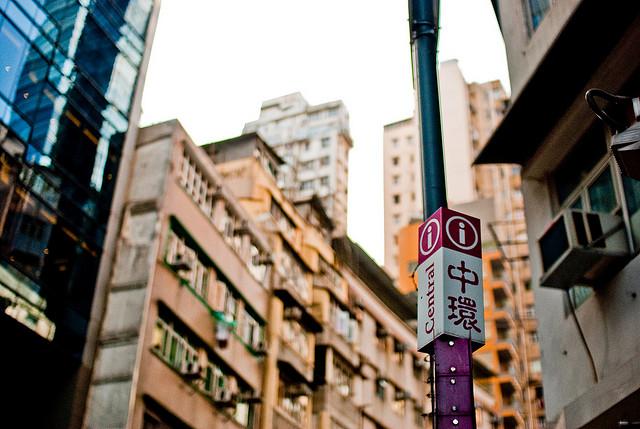How many languages is this sign in?
Concise answer only. 2. Where was the picture taken of the sign?
Quick response, please. China. Can you pick out the most modern building in this photo?
Answer briefly. Yes. 